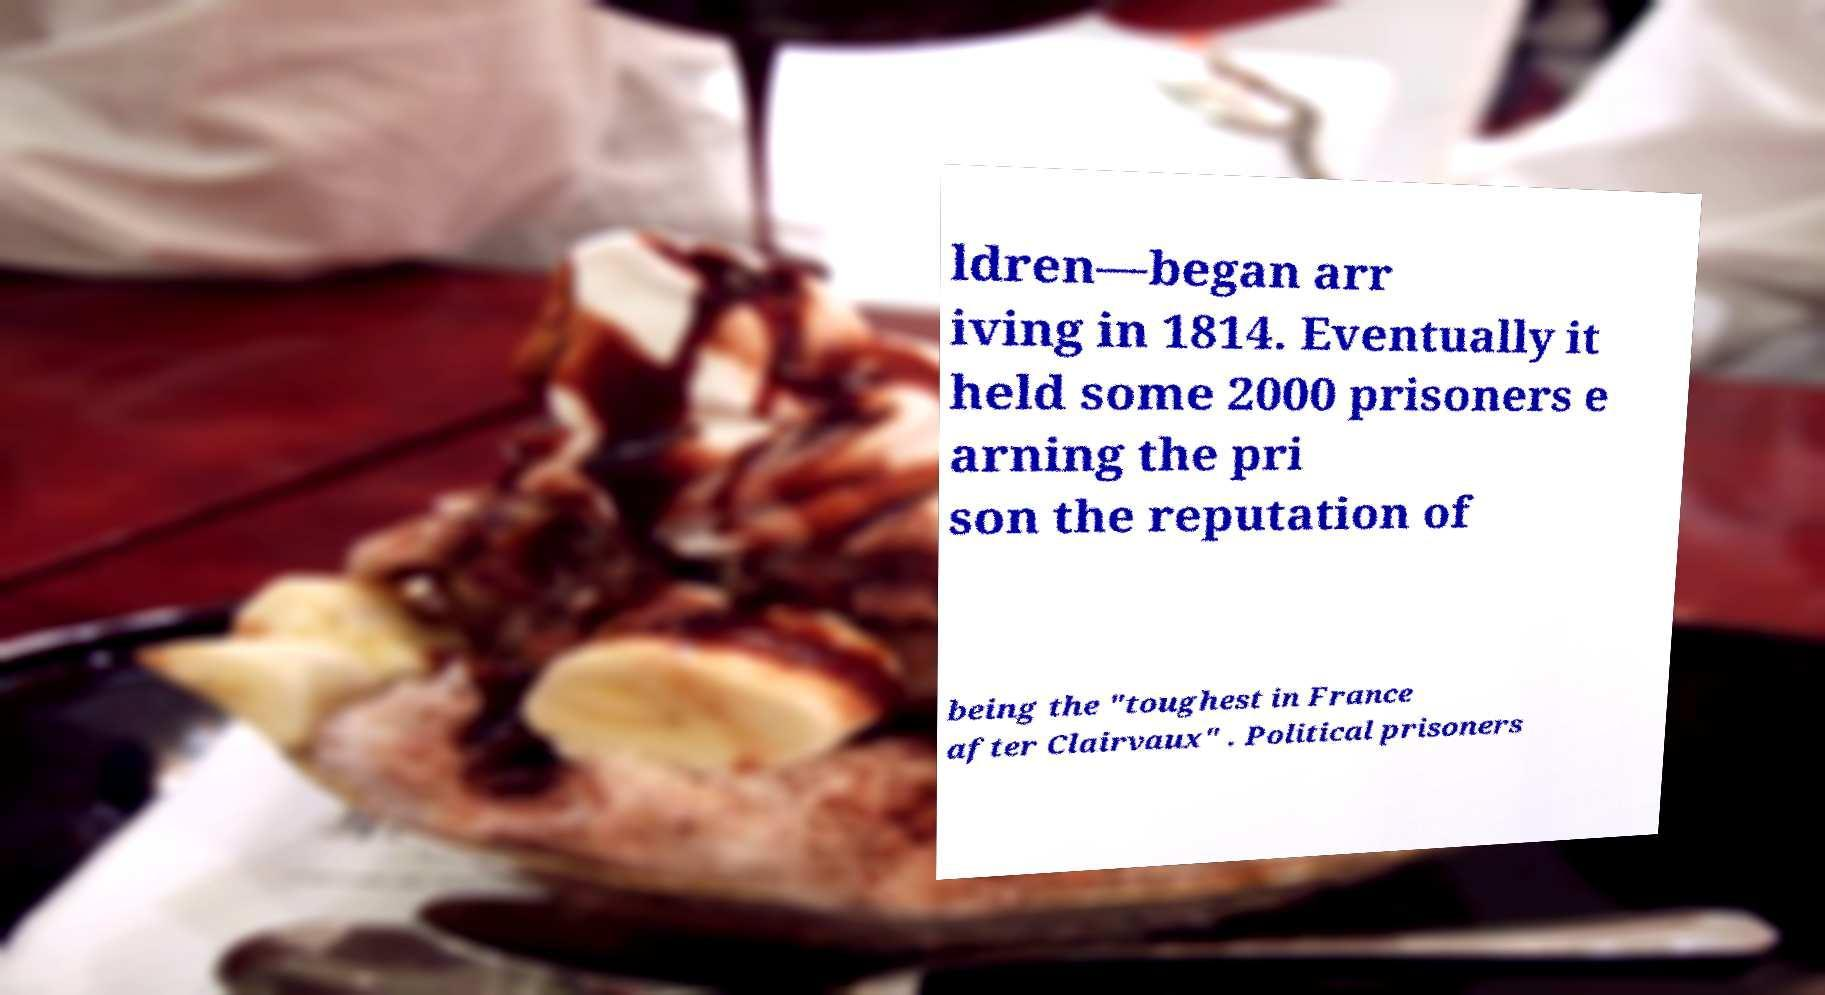I need the written content from this picture converted into text. Can you do that? ldren—began arr iving in 1814. Eventually it held some 2000 prisoners e arning the pri son the reputation of being the "toughest in France after Clairvaux" . Political prisoners 